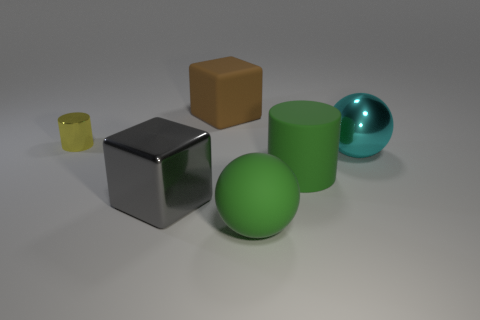There is a cylinder that is the same size as the cyan thing; what is its material?
Give a very brief answer. Rubber. What color is the metallic object right of the large rubber thing that is in front of the big green cylinder?
Offer a terse response. Cyan. There is a big brown matte thing; what number of brown cubes are behind it?
Keep it short and to the point. 0. The large metallic block is what color?
Your answer should be very brief. Gray. What number of tiny objects are blue metallic cubes or gray metallic blocks?
Offer a very short reply. 0. Does the matte thing that is behind the cyan sphere have the same color as the block that is in front of the small yellow cylinder?
Provide a short and direct response. No. What number of other objects are there of the same color as the matte cylinder?
Your answer should be very brief. 1. There is a big rubber thing behind the yellow metal cylinder; what is its shape?
Offer a very short reply. Cube. Are there fewer big rubber cylinders than big brown cylinders?
Your answer should be very brief. No. Are the cube behind the shiny sphere and the large cyan ball made of the same material?
Provide a succinct answer. No. 